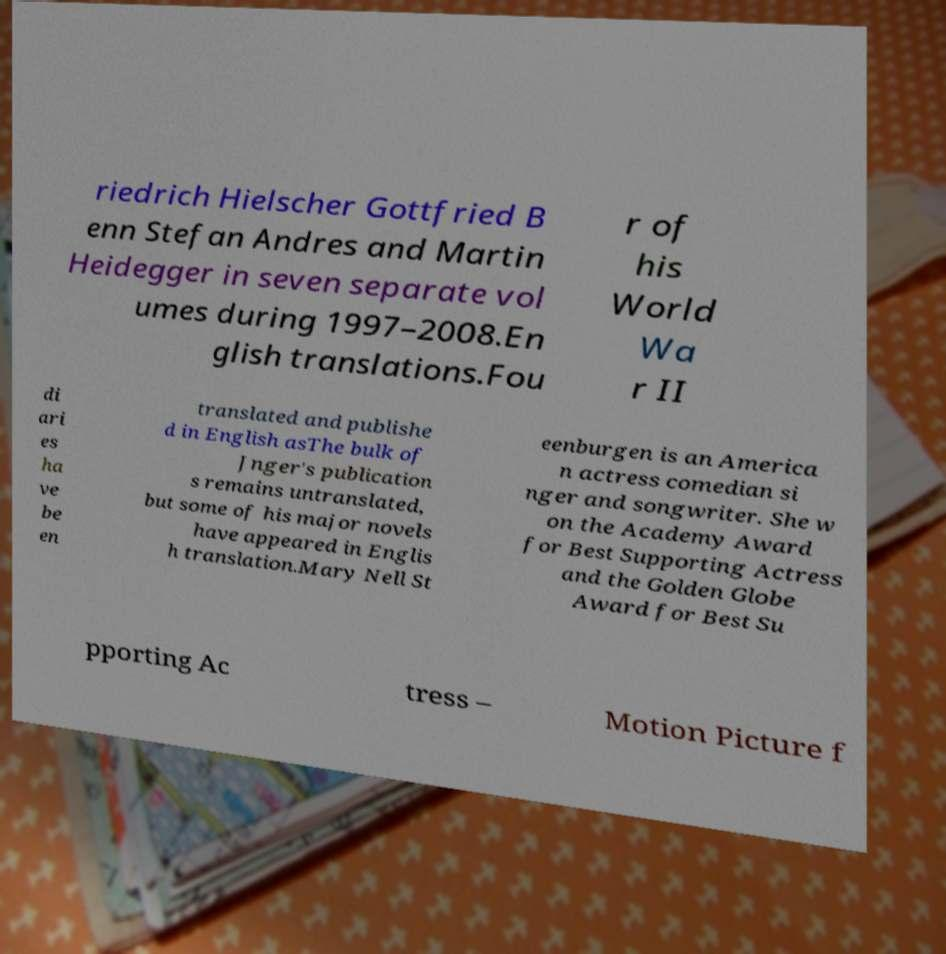Can you accurately transcribe the text from the provided image for me? riedrich Hielscher Gottfried B enn Stefan Andres and Martin Heidegger in seven separate vol umes during 1997–2008.En glish translations.Fou r of his World Wa r II di ari es ha ve be en translated and publishe d in English asThe bulk of Jnger's publication s remains untranslated, but some of his major novels have appeared in Englis h translation.Mary Nell St eenburgen is an America n actress comedian si nger and songwriter. She w on the Academy Award for Best Supporting Actress and the Golden Globe Award for Best Su pporting Ac tress – Motion Picture f 